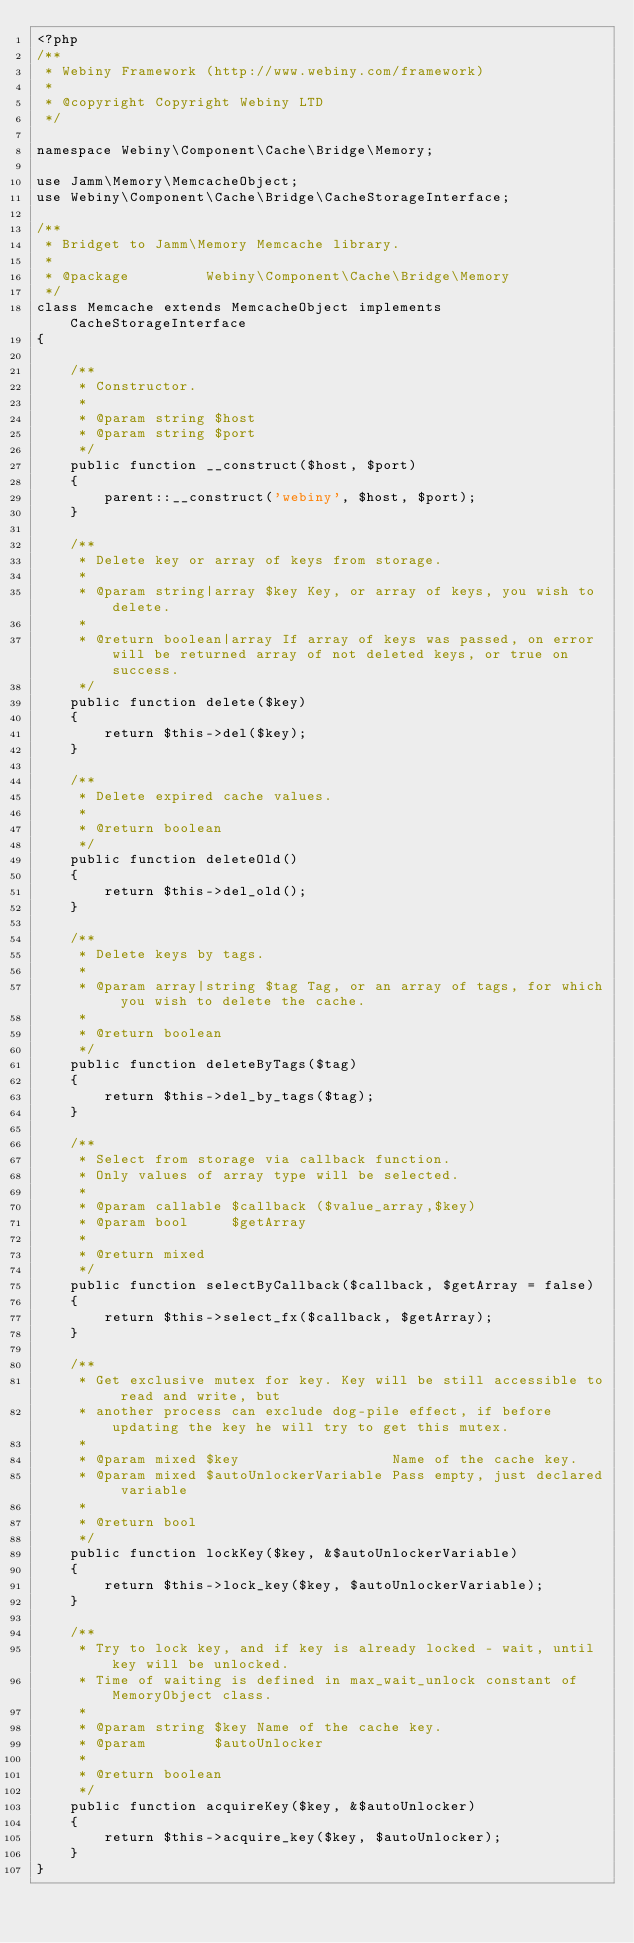Convert code to text. <code><loc_0><loc_0><loc_500><loc_500><_PHP_><?php
/**
 * Webiny Framework (http://www.webiny.com/framework)
 *
 * @copyright Copyright Webiny LTD
 */

namespace Webiny\Component\Cache\Bridge\Memory;

use Jamm\Memory\MemcacheObject;
use Webiny\Component\Cache\Bridge\CacheStorageInterface;

/**
 * Bridget to Jamm\Memory Memcache library.
 *
 * @package         Webiny\Component\Cache\Bridge\Memory
 */
class Memcache extends MemcacheObject implements CacheStorageInterface
{

    /**
     * Constructor.
     *
     * @param string $host
     * @param string $port
     */
    public function __construct($host, $port)
    {
        parent::__construct('webiny', $host, $port);
    }

    /**
     * Delete key or array of keys from storage.
     *
     * @param string|array $key Key, or array of keys, you wish to delete.
     *
     * @return boolean|array If array of keys was passed, on error will be returned array of not deleted keys, or true on success.
     */
    public function delete($key)
    {
        return $this->del($key);
    }

    /**
     * Delete expired cache values.
     *
     * @return boolean
     */
    public function deleteOld()
    {
        return $this->del_old();
    }

    /**
     * Delete keys by tags.
     *
     * @param array|string $tag Tag, or an array of tags, for which you wish to delete the cache.
     *
     * @return boolean
     */
    public function deleteByTags($tag)
    {
        return $this->del_by_tags($tag);
    }

    /**
     * Select from storage via callback function.
     * Only values of array type will be selected.
     *
     * @param callable $callback ($value_array,$key)
     * @param bool     $getArray
     *
     * @return mixed
     */
    public function selectByCallback($callback, $getArray = false)
    {
        return $this->select_fx($callback, $getArray);
    }

    /**
     * Get exclusive mutex for key. Key will be still accessible to read and write, but
     * another process can exclude dog-pile effect, if before updating the key he will try to get this mutex.
     *
     * @param mixed $key                  Name of the cache key.
     * @param mixed $autoUnlockerVariable Pass empty, just declared variable
     *
     * @return bool
     */
    public function lockKey($key, &$autoUnlockerVariable)
    {
        return $this->lock_key($key, $autoUnlockerVariable);
    }

    /**
     * Try to lock key, and if key is already locked - wait, until key will be unlocked.
     * Time of waiting is defined in max_wait_unlock constant of MemoryObject class.
     *
     * @param string $key Name of the cache key.
     * @param        $autoUnlocker
     *
     * @return boolean
     */
    public function acquireKey($key, &$autoUnlocker)
    {
        return $this->acquire_key($key, $autoUnlocker);
    }
}</code> 